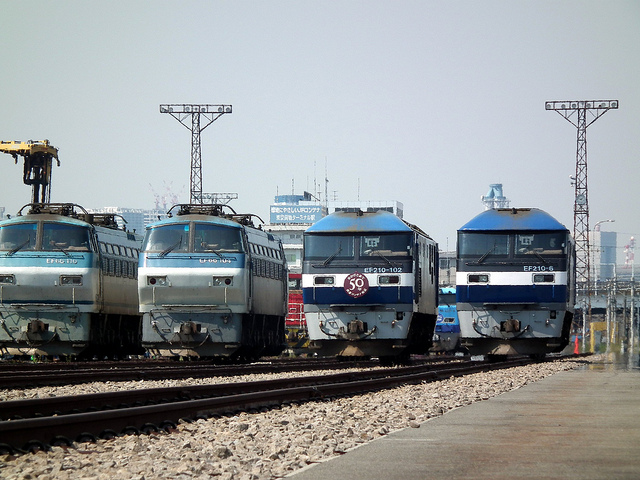Read and extract the text from this image. EF210 102 50 210 